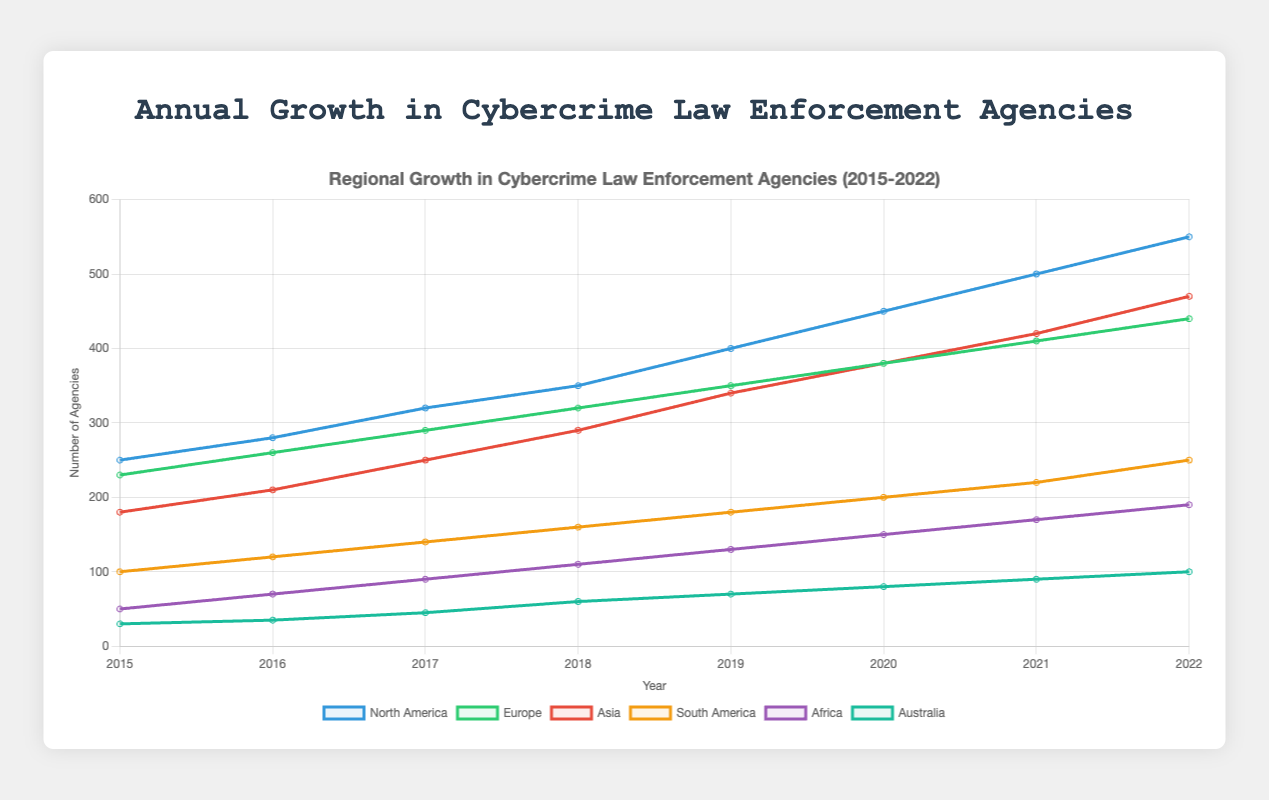What's the total number of agencies in 2018 across all regions? Look at the data point for each region in 2018 and sum them up: North America (350) + Europe (320) + Asia (290) + South America (160) + Africa (110) + Australia (60) = 1290
Answer: 1290 Which region showed the greatest increase in the number of agencies from 2017 to 2018? Compare the number of agencies in each region in 2017 and 2018. Calculate the difference for each region: North America (350-320=30), Europe (320-290=30), Asia (290-250=40), South America (160-140=20), Africa (110-90=20), Australia (60-45=15). The greatest increase is in Asia (40)
Answer: Asia Among the regions, which had the lowest number of agencies in 2019? Look at the 2019 data and identify the region with the smallest number: North America (400), Europe (350), Asia (340), South America (180), Africa (130), Australia (70). The lowest is Australia (70)
Answer: Australia What was the average number of agencies in Europe over the entire period (2015-2022)? Sum the number of agencies in Europe for each year (230+260+290+320+350+380+410+440=2680) and then divide by the number of years (8): 2680 / 8 = 335
Answer: 335 How many more agencies did North America have compared to Africa in 2022? Subtract the number of agencies in Africa from the number of agencies in North America for 2022: North America (550) - Africa (190) = 360
Answer: 360 In which year did the number of agencies in South America surpass 150? Look at the data for South America and identify the first year the number exceeds 150: 100 (2015), 120 (2016), 140 (2017), 160 (2018) – 2018 is the year it surpasses 150
Answer: 2018 Which region has the steepest upward trend over the years? Compare the slope of the lines representing each region from 2015 to 2022. The North America line is the steepest with the largest increase from 250 to 550 (a difference of 300)
Answer: North America 